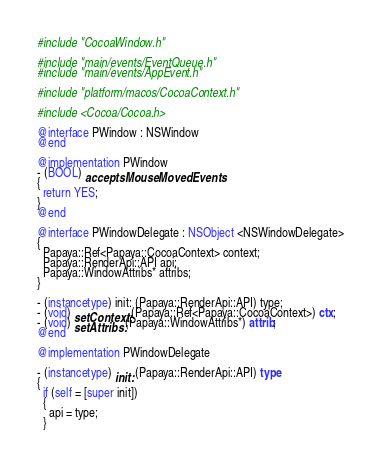<code> <loc_0><loc_0><loc_500><loc_500><_ObjectiveC_>#include "CocoaWindow.h"

#include "main/events/EventQueue.h"
#include "main/events/AppEvent.h"

#include "platform/macos/CocoaContext.h"

#include <Cocoa/Cocoa.h>

@interface PWindow : NSWindow
@end

@implementation PWindow
- (BOOL) acceptsMouseMovedEvents
{
  return YES;
}
@end

@interface PWindowDelegate : NSObject <NSWindowDelegate>
{
  Papaya::Ref<Papaya::CocoaContext> context;
  Papaya::RenderApi::API api;
  Papaya::WindowAttribs* attribs;
}

- (instancetype) init: (Papaya::RenderApi::API) type;
- (void) setContext: (Papaya::Ref<Papaya::CocoaContext>) ctx;
- (void) setAttribs: (Papaya::WindowAttribs*) attrib;
@end

@implementation PWindowDelegate

- (instancetype) init: (Papaya::RenderApi::API) type
{
  if (self = [super init])
  {
    api = type;
  }</code> 